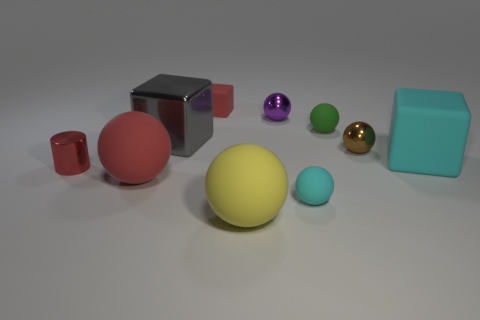Subtract all small brown spheres. How many spheres are left? 5 Subtract 1 blocks. How many blocks are left? 2 Subtract all yellow balls. How many balls are left? 5 Subtract all green cubes. Subtract all gray spheres. How many cubes are left? 3 Subtract all cylinders. How many objects are left? 9 Add 4 large red rubber objects. How many large red rubber objects are left? 5 Add 3 big green cylinders. How many big green cylinders exist? 3 Subtract 1 red blocks. How many objects are left? 9 Subtract all gray metal things. Subtract all purple shiny objects. How many objects are left? 8 